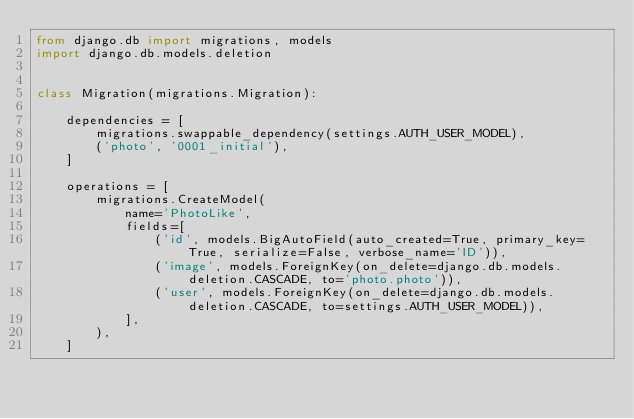Convert code to text. <code><loc_0><loc_0><loc_500><loc_500><_Python_>from django.db import migrations, models
import django.db.models.deletion


class Migration(migrations.Migration):

    dependencies = [
        migrations.swappable_dependency(settings.AUTH_USER_MODEL),
        ('photo', '0001_initial'),
    ]

    operations = [
        migrations.CreateModel(
            name='PhotoLike',
            fields=[
                ('id', models.BigAutoField(auto_created=True, primary_key=True, serialize=False, verbose_name='ID')),
                ('image', models.ForeignKey(on_delete=django.db.models.deletion.CASCADE, to='photo.photo')),
                ('user', models.ForeignKey(on_delete=django.db.models.deletion.CASCADE, to=settings.AUTH_USER_MODEL)),
            ],
        ),
    ]
</code> 